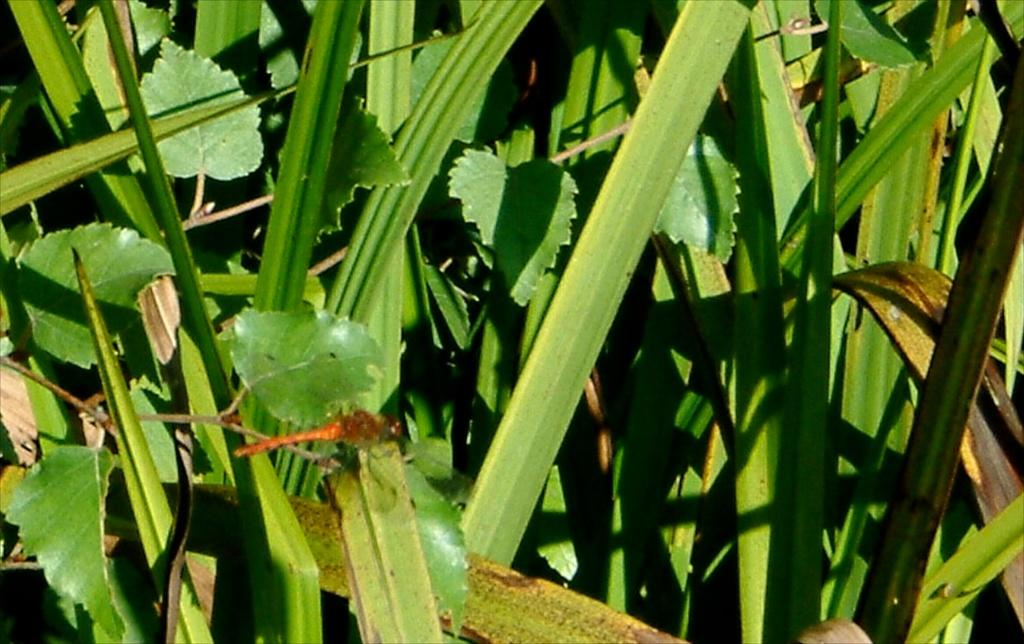What is the main subject in the foreground of the image? There is a dragonfly in the foreground of the image. Where is the dragonfly located? The dragonfly is on a leaf. What can be seen in the background of the image? There are plants visible in the background of the image. How many clocks can be seen hanging on the rose in the image? There are no clocks or roses present in the image; it features a dragonfly on a leaf with plants in the background. 